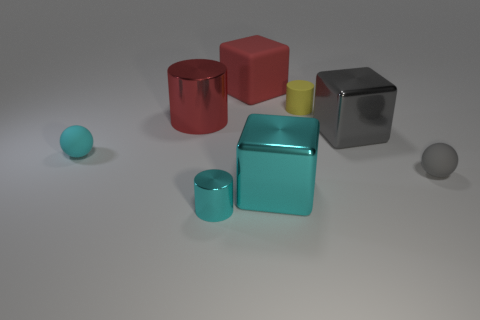Add 2 small objects. How many objects exist? 10 Subtract all cubes. How many objects are left? 5 Subtract 0 green balls. How many objects are left? 8 Subtract all large gray metallic blocks. Subtract all yellow rubber cylinders. How many objects are left? 6 Add 2 cyan things. How many cyan things are left? 5 Add 1 matte cylinders. How many matte cylinders exist? 2 